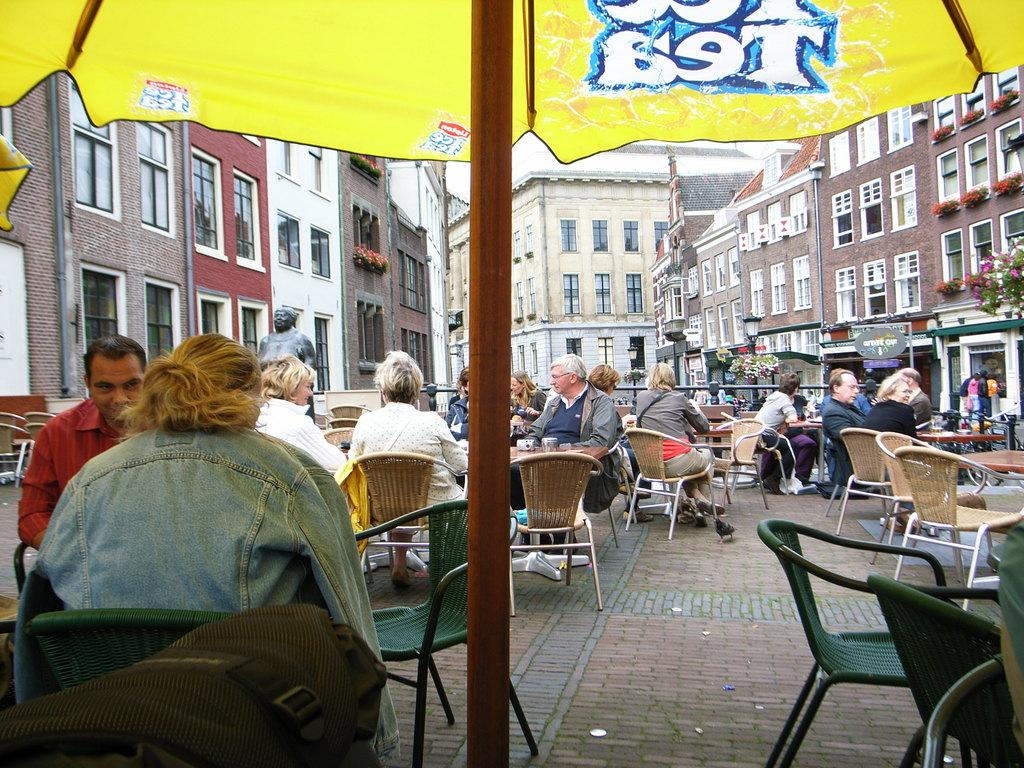Where was the image taken? The image is taken outdoors. What are the people in the image doing? The people are sitting on chairs in the image. What can be seen in the background of the image? There are buildings in the background of the image. Is there any other object or structure visible in the image? Yes, there is a pole in the image. What type of appliance can be seen hanging from the pole in the image? There is no appliance hanging from the pole in the image. Are there any mice visible in the image? There are no mice present in the image. 